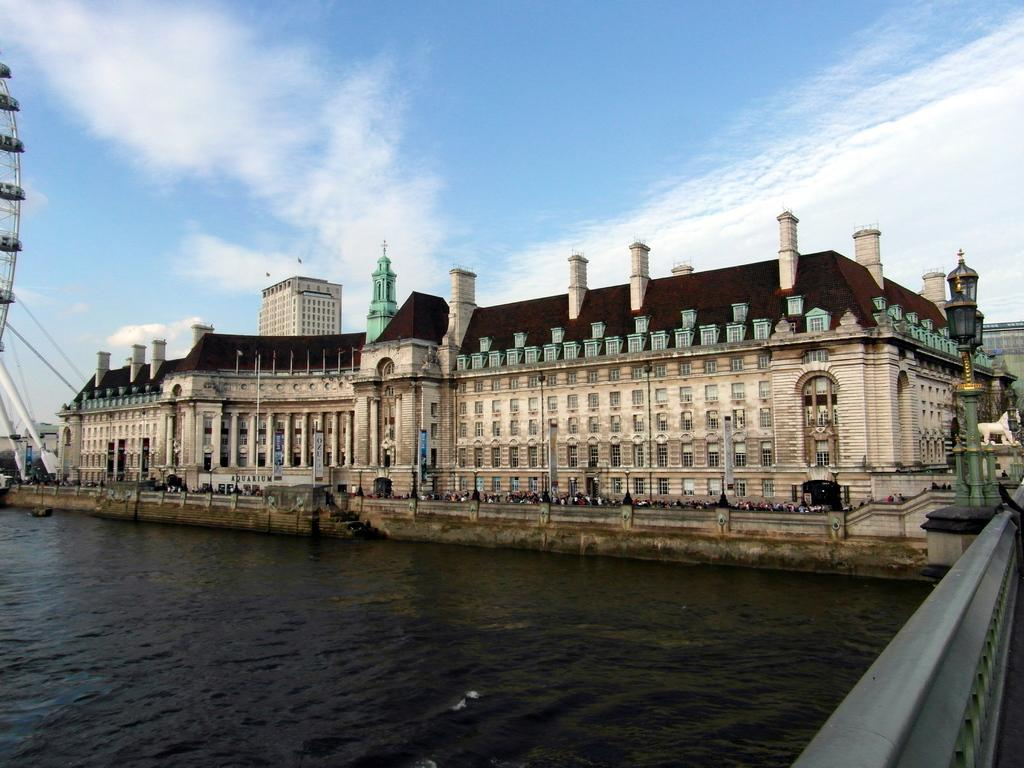What type of structures can be seen in the image? There are buildings in the image. Where are the buildings located in relation to the sea? The buildings are in front of the sea. What is located on the right side of the image? There is a pole on the right side of the image. What can be seen in the background of the image? The sky is visible in the background of the image. Can you tell me how many goldfish are swimming in the sea in the image? There are no goldfish visible in the image; it features buildings in front of the sea. What type of doctor is attending to the buildings in the image? There is no doctor present in the image; it only shows buildings, a pole, and the sea. 